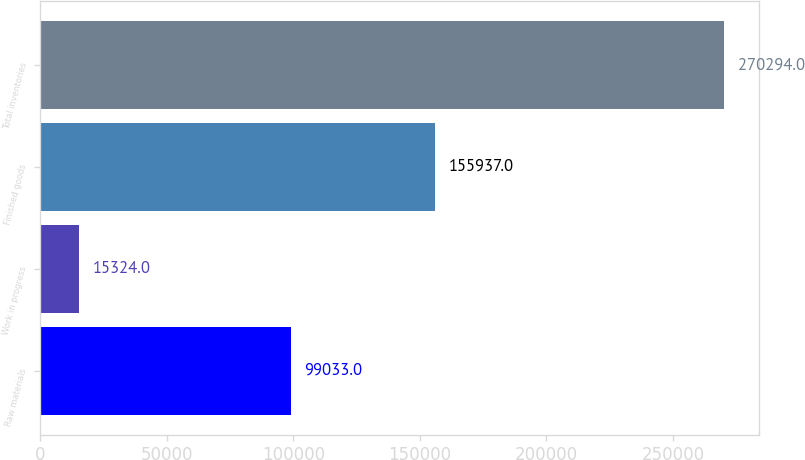Convert chart to OTSL. <chart><loc_0><loc_0><loc_500><loc_500><bar_chart><fcel>Raw materials<fcel>Work in progress<fcel>Finished goods<fcel>Total inventories<nl><fcel>99033<fcel>15324<fcel>155937<fcel>270294<nl></chart> 